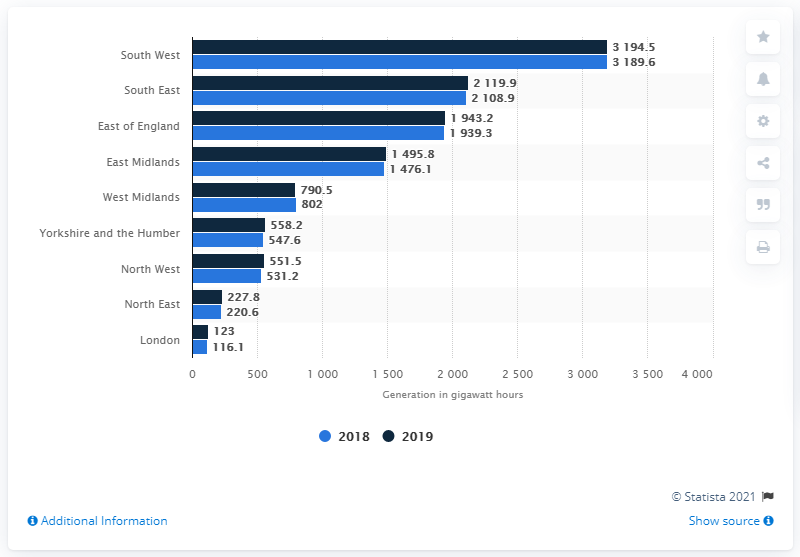Identify some key points in this picture. The region with the highest amount of solar power generation was the South East. London had the least amount of solar electricity generation among all the regions. In 2019, the South West region of England generated the most electricity from solar power. 